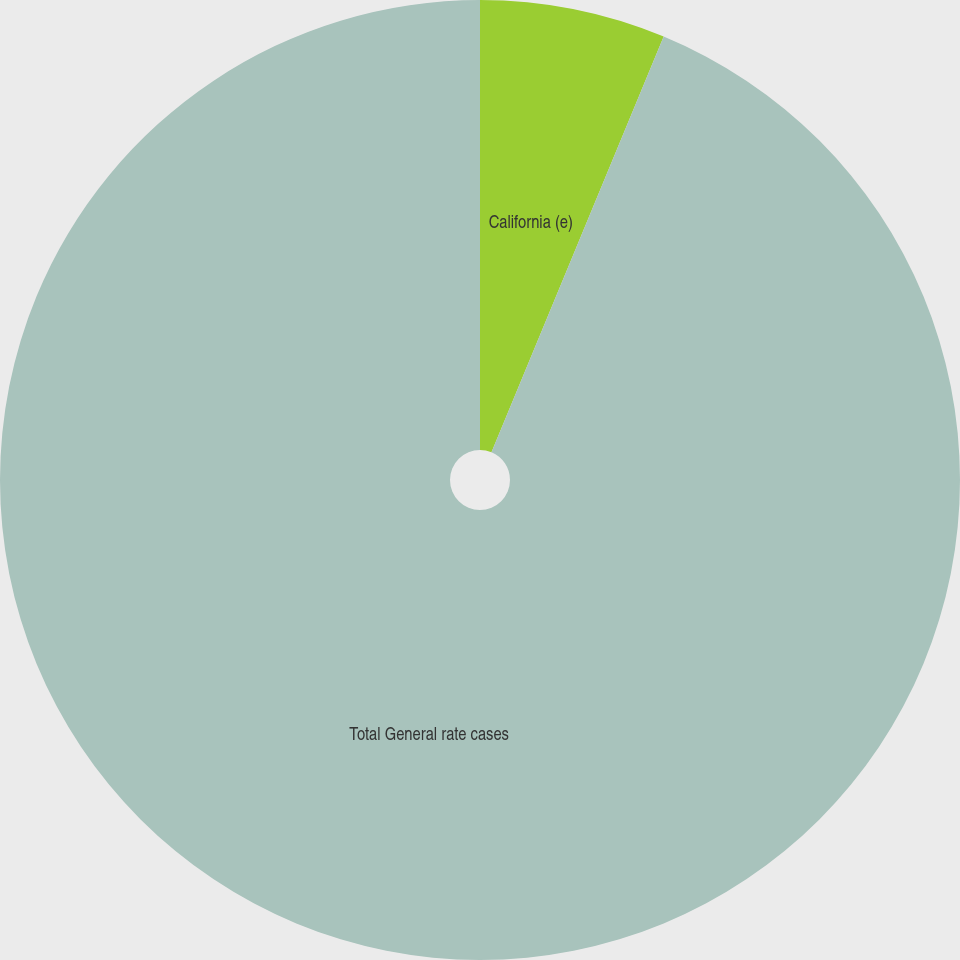Convert chart to OTSL. <chart><loc_0><loc_0><loc_500><loc_500><pie_chart><fcel>California (e)<fcel>Total General rate cases<nl><fcel>6.25%<fcel>93.75%<nl></chart> 